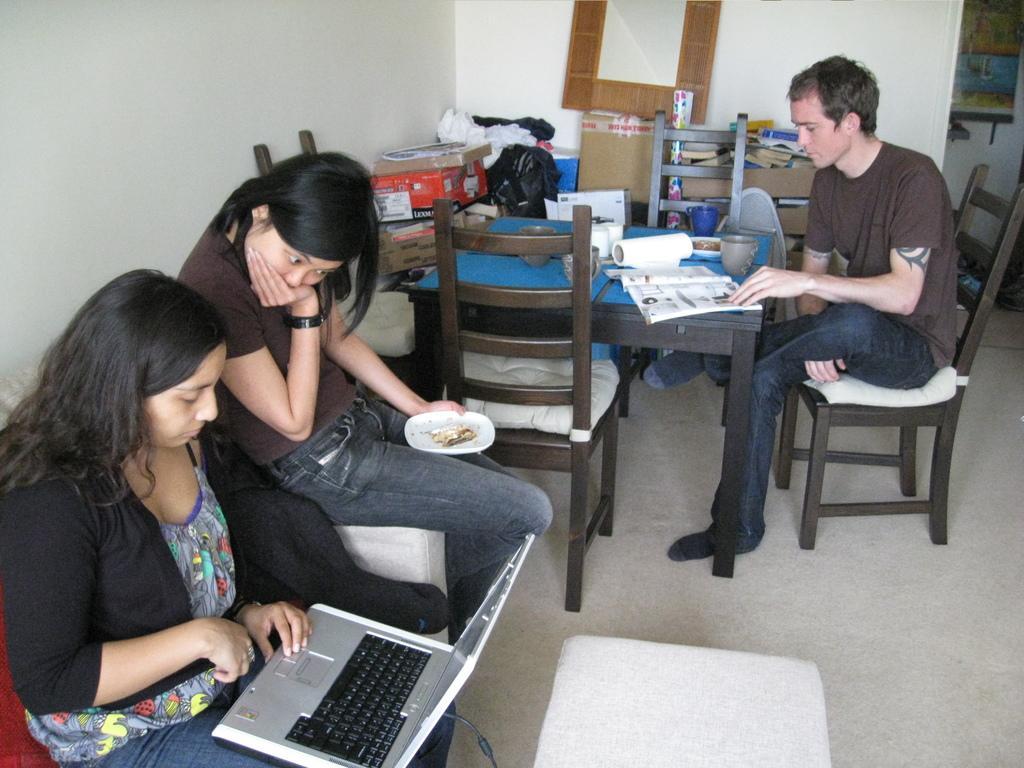Can you describe this image briefly? In the picture we can see three people, two are women and one is man, they are sitting on chairs. On e women is holding a laptop and working, and another woman is holding a plate with food. The man is reading a book on a table. And on the table we can see some things like cup, papers, boxes, are kept on it. In the background we can see a wall and a frame with wooden. 